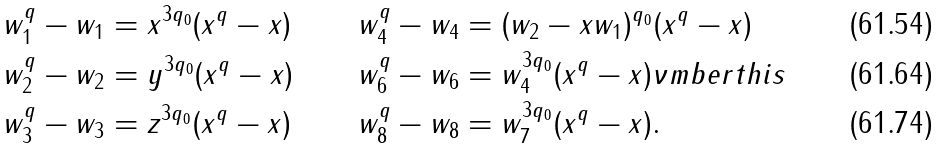<formula> <loc_0><loc_0><loc_500><loc_500>w _ { 1 } ^ { q } - w _ { 1 } & = x ^ { 3 q _ { 0 } } ( x ^ { q } - x ) & w _ { 4 } ^ { q } - w _ { 4 } & = ( w _ { 2 } - x w _ { 1 } ) ^ { q _ { 0 } } ( x ^ { q } - x ) \\ w _ { 2 } ^ { q } - w _ { 2 } & = y ^ { 3 q _ { 0 } } ( x ^ { q } - x ) & w _ { 6 } ^ { q } - w _ { 6 } & = w _ { 4 } ^ { 3 q _ { 0 } } ( x ^ { q } - x ) \nu m b e r t h i s \\ w _ { 3 } ^ { q } - w _ { 3 } & = z ^ { 3 q _ { 0 } } ( x ^ { q } - x ) & w _ { 8 } ^ { q } - w _ { 8 } & = w _ { 7 } ^ { 3 q _ { 0 } } ( x ^ { q } - x ) .</formula> 